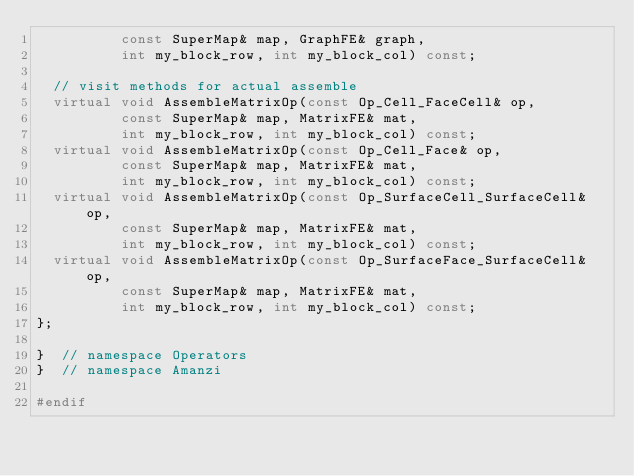Convert code to text. <code><loc_0><loc_0><loc_500><loc_500><_C++_>          const SuperMap& map, GraphFE& graph,
          int my_block_row, int my_block_col) const;
  
  // visit methods for actual assemble
  virtual void AssembleMatrixOp(const Op_Cell_FaceCell& op,
          const SuperMap& map, MatrixFE& mat,
          int my_block_row, int my_block_col) const;
  virtual void AssembleMatrixOp(const Op_Cell_Face& op,
          const SuperMap& map, MatrixFE& mat,
          int my_block_row, int my_block_col) const;
  virtual void AssembleMatrixOp(const Op_SurfaceCell_SurfaceCell& op,
          const SuperMap& map, MatrixFE& mat,
          int my_block_row, int my_block_col) const;
  virtual void AssembleMatrixOp(const Op_SurfaceFace_SurfaceCell& op,
          const SuperMap& map, MatrixFE& mat,
          int my_block_row, int my_block_col) const;
};

}  // namespace Operators
}  // namespace Amanzi

#endif

    

</code> 